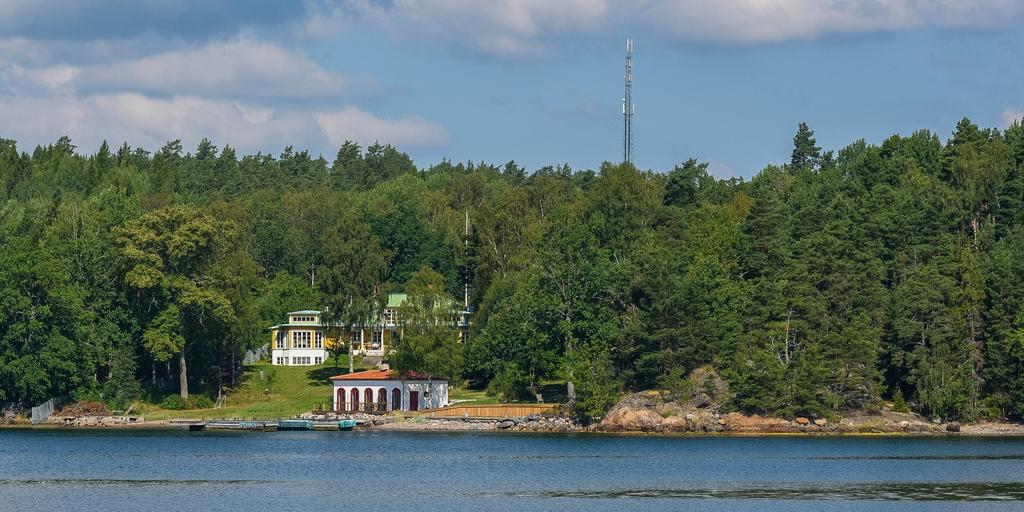What is visible in the image? Water is visible in the image. What can be seen in the background of the image? There are trees, houses, a tower, and the sky in the background of the image. Can you describe the sky in the image? The sky is clear in the background of the image, with some clouds visible. What type of mass is being developed in the image? There is no reference to mass or development in the image; it primarily features water, trees, houses, a tower, and the sky. 